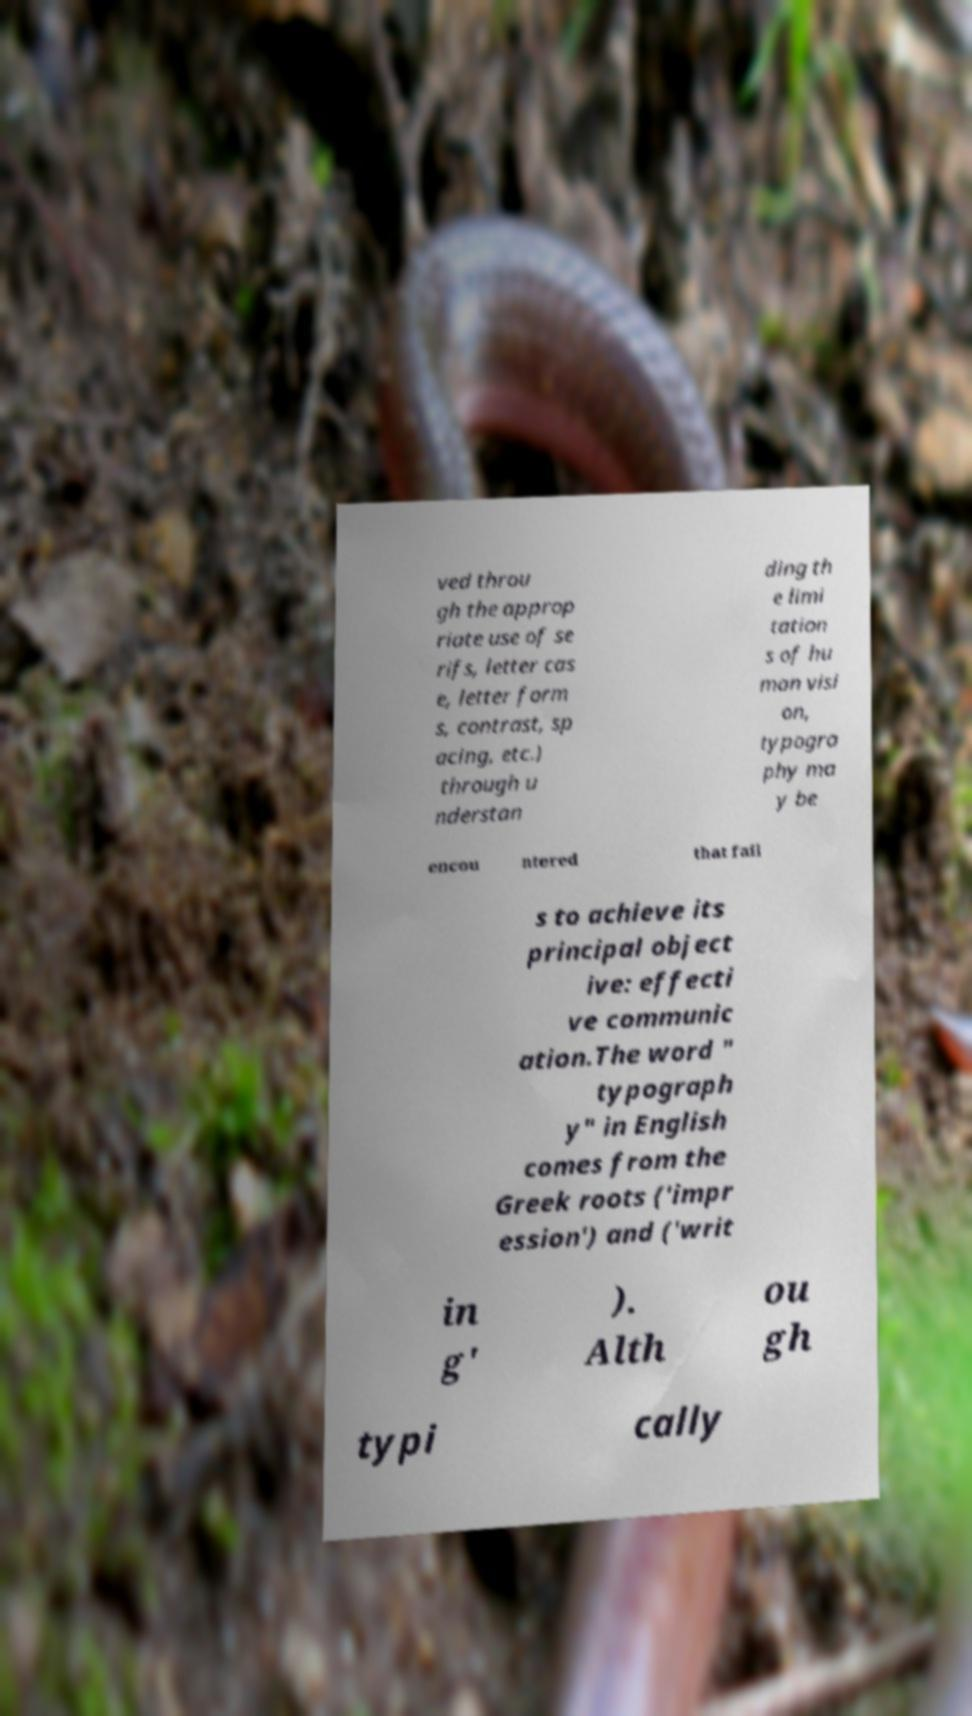Can you accurately transcribe the text from the provided image for me? ved throu gh the approp riate use of se rifs, letter cas e, letter form s, contrast, sp acing, etc.) through u nderstan ding th e limi tation s of hu man visi on, typogra phy ma y be encou ntered that fail s to achieve its principal object ive: effecti ve communic ation.The word " typograph y" in English comes from the Greek roots ('impr ession') and ('writ in g' ). Alth ou gh typi cally 